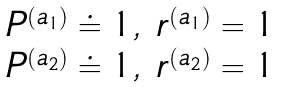Convert formula to latex. <formula><loc_0><loc_0><loc_500><loc_500>\begin{array} { c c } P ^ { ( a _ { 1 } ) } \doteq 1 , & r ^ { ( a _ { 1 } ) } = 1 \\ P ^ { ( a _ { 2 } ) } \doteq 1 , & r ^ { ( a _ { 2 } ) } = 1 \end{array}</formula> 